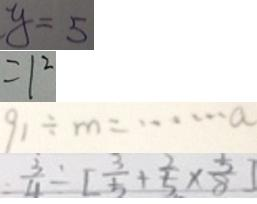<formula> <loc_0><loc_0><loc_500><loc_500>y = 5 
 = 1 ^ { 2 } 
 9 1 \div m = \cdots a 
 = \frac { 3 } { 4 } \div [ \frac { 3 } { 5 } + \frac { 2 } { 5 } \times \frac { 5 } { 8 } ]</formula> 